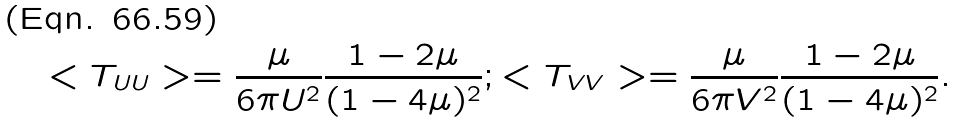<formula> <loc_0><loc_0><loc_500><loc_500>< T _ { U U } > = \frac { \mu } { 6 \pi U ^ { 2 } } \frac { 1 - 2 \mu } { ( 1 - 4 \mu ) ^ { 2 } } ; < T _ { V V } > = \frac { \mu } { 6 \pi V ^ { 2 } } \frac { 1 - 2 \mu } { ( 1 - 4 \mu ) ^ { 2 } } .</formula> 